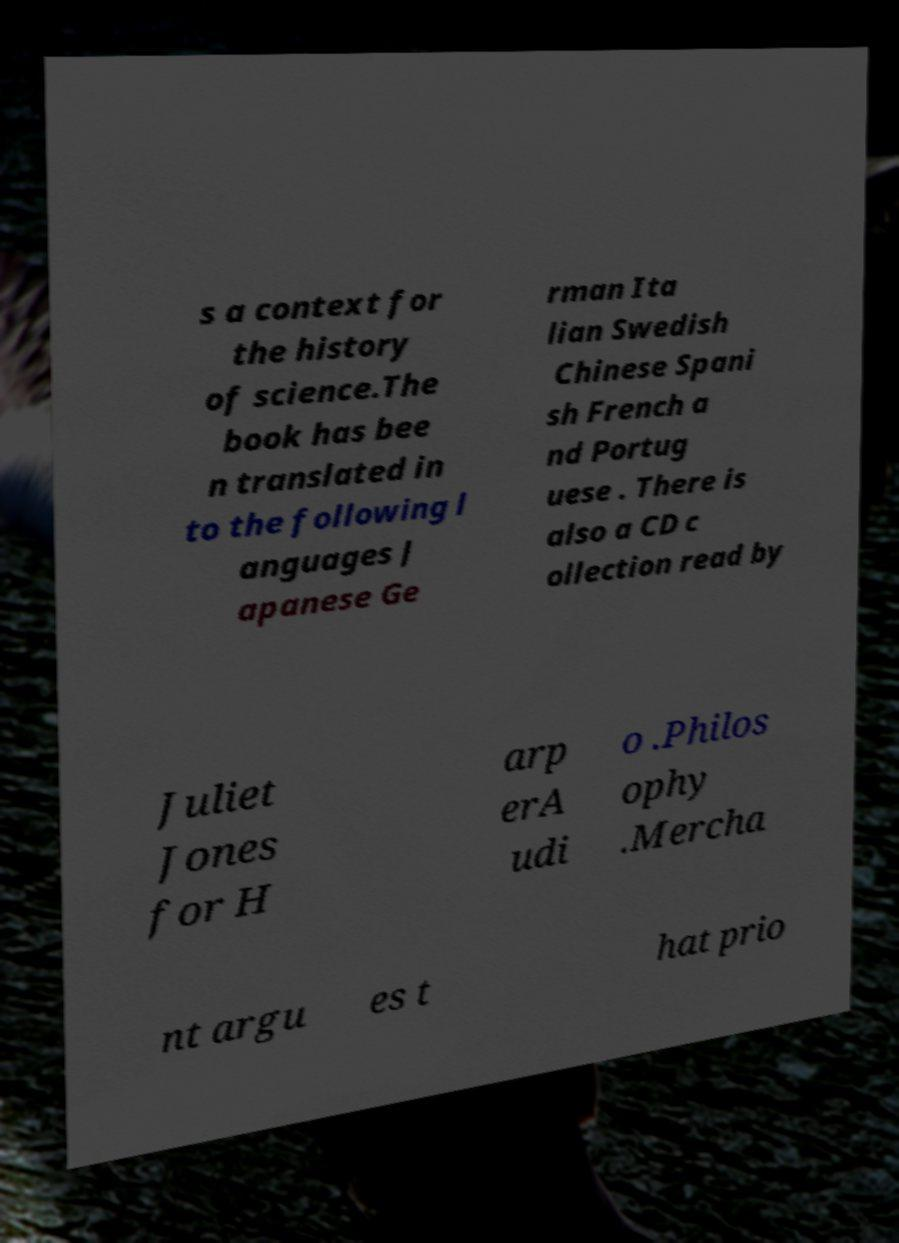Could you extract and type out the text from this image? s a context for the history of science.The book has bee n translated in to the following l anguages J apanese Ge rman Ita lian Swedish Chinese Spani sh French a nd Portug uese . There is also a CD c ollection read by Juliet Jones for H arp erA udi o .Philos ophy .Mercha nt argu es t hat prio 